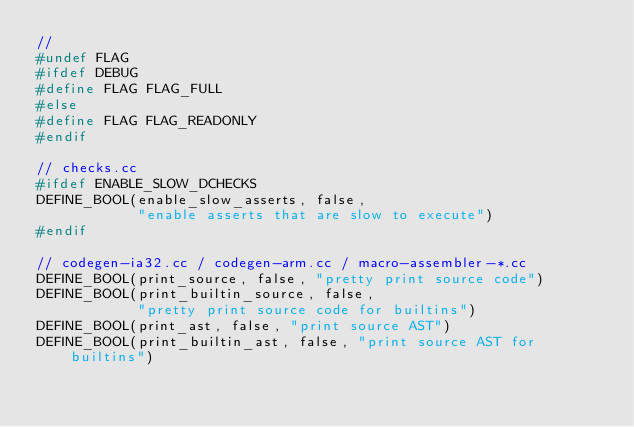<code> <loc_0><loc_0><loc_500><loc_500><_C_>//
#undef FLAG
#ifdef DEBUG
#define FLAG FLAG_FULL
#else
#define FLAG FLAG_READONLY
#endif

// checks.cc
#ifdef ENABLE_SLOW_DCHECKS
DEFINE_BOOL(enable_slow_asserts, false,
            "enable asserts that are slow to execute")
#endif

// codegen-ia32.cc / codegen-arm.cc / macro-assembler-*.cc
DEFINE_BOOL(print_source, false, "pretty print source code")
DEFINE_BOOL(print_builtin_source, false,
            "pretty print source code for builtins")
DEFINE_BOOL(print_ast, false, "print source AST")
DEFINE_BOOL(print_builtin_ast, false, "print source AST for builtins")</code> 